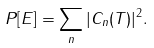<formula> <loc_0><loc_0><loc_500><loc_500>P [ E ] = \sum _ { n } | C _ { n } ( T ) | ^ { 2 } .</formula> 